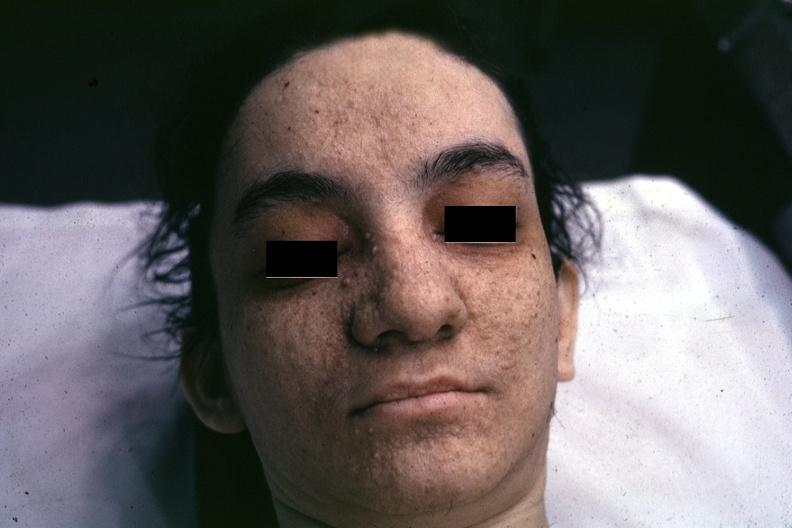s lesion of myocytolysis present?
Answer the question using a single word or phrase. No 